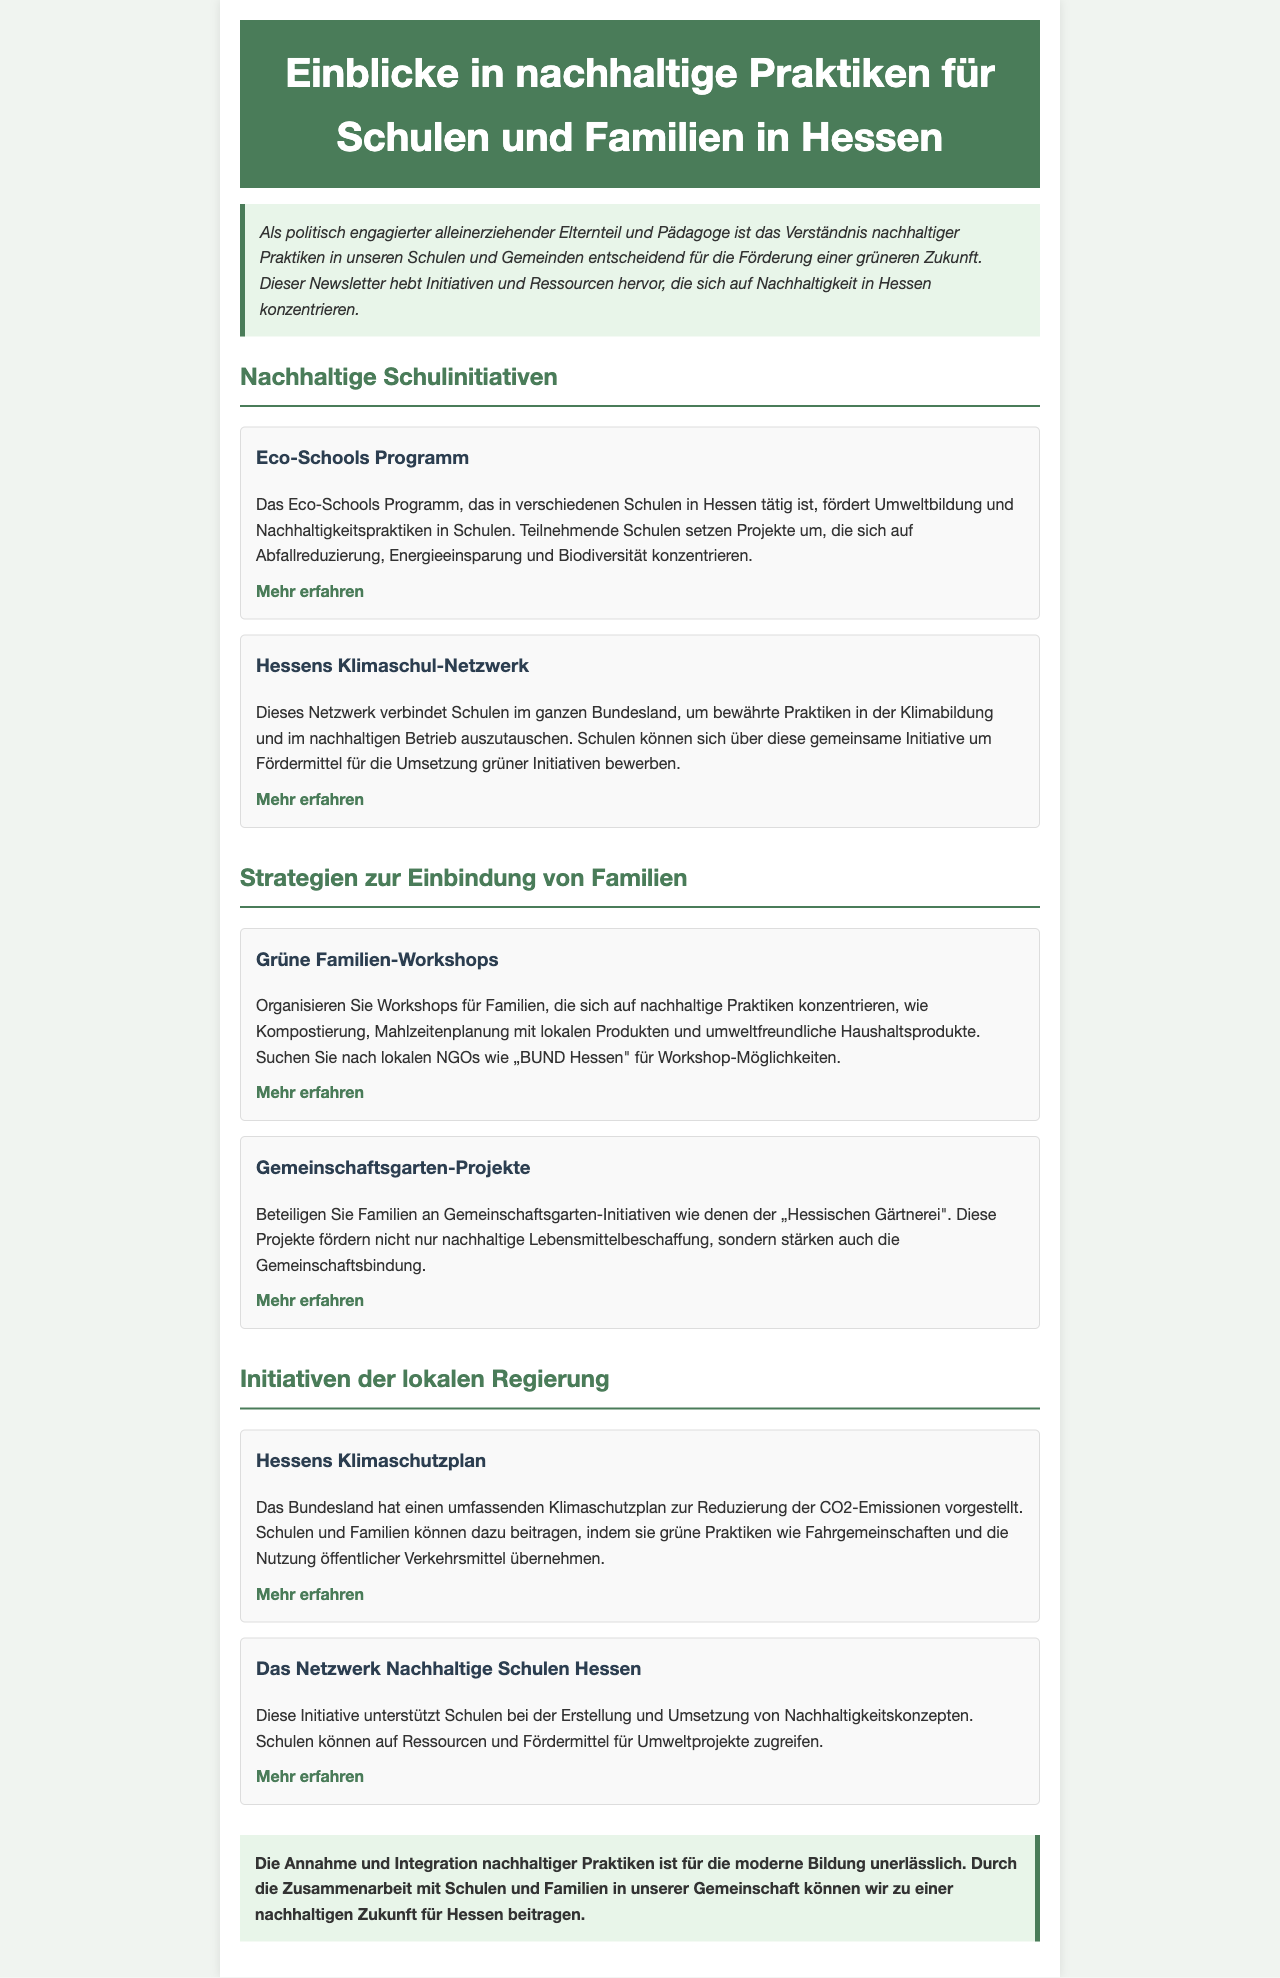Was ist das Eco-Schools Programm? Das Eco-Schools Programm fördert Umweltbildung und Nachhaltigkeitspraktiken in Schulen.
Answer: Umweltbildung und Nachhaltigkeitspraktiken Wie können Schulen auf das Klimaschul-Netzwerk zugreifen? Schulen können sich um Fördermittel für die Umsetzung grüner Initiativen bewerben.
Answer: Fördermittel Welche Organisatoren bieten Workshops für nachhaltige Praktiken an? Lokale NGOs wie „BUND Hessen" bieten Workshops an.
Answer: BUND Hessen Was ist das Ziel von Hessens Klimaschutzplan? Das Ziel ist die Reduzierung der CO2-Emissionen.
Answer: Reduzierung der CO2-Emissionen Wie fördern Gemeinschaftsgarten-Projekte die Gemeinschaft? Diese Projekte stärken die Gemeinschaftsbindung.
Answer: Gemeinschaftsbindung Welche Art von Konzepten unterstützt das Netzwerk Nachhaltige Schulen Hessen? Das Netzwerk unterstützt Nachhaltigkeitskonzepte.
Answer: Nachhaltigkeitskonzepte Was steht in der Einleitung des Newsletters? Die Einleitung hebt Initiativen und Ressourcen hervor, die sich auf Nachhaltigkeit in Hessen konzentrieren.
Answer: Initiativen und Ressourcen für Nachhaltigkeit Wie nennt man die Aktivitäten von Schulen im Klimabildungs-Netzwerk? Diese Aktivitäten sind bewährte Praktiken im Bereich Klimabildung.
Answer: Bewährte Praktiken Was wird in den grünen Familien-Workshops gelehrt? In den Workshops wird über nachhaltige Praktiken unterrichtet.
Answer: Nachhaltige Praktiken 